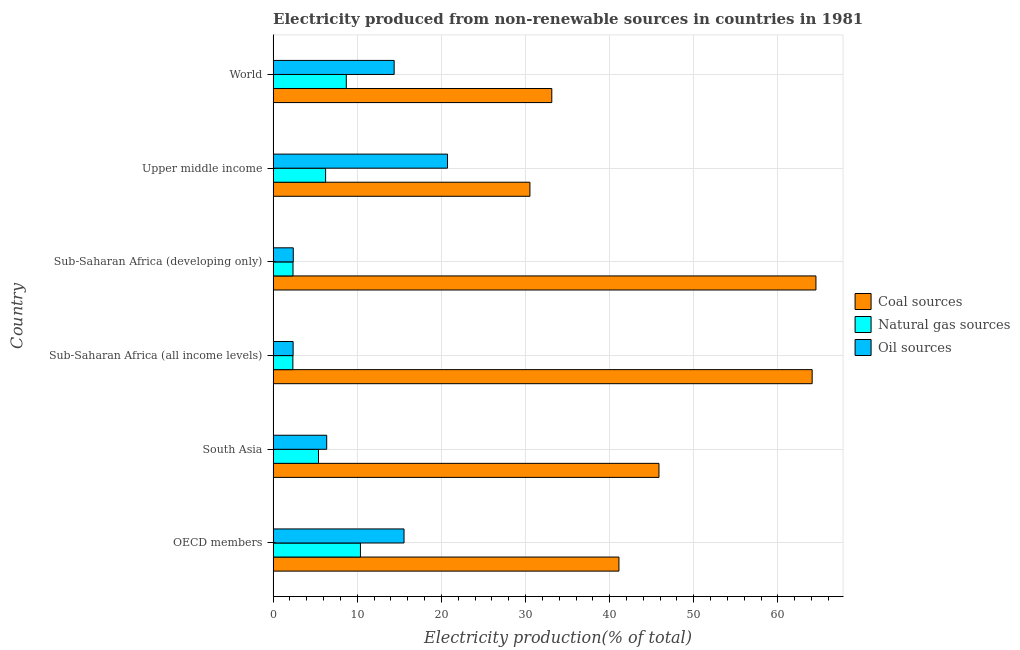Are the number of bars per tick equal to the number of legend labels?
Provide a succinct answer. Yes. Are the number of bars on each tick of the Y-axis equal?
Give a very brief answer. Yes. How many bars are there on the 5th tick from the top?
Keep it short and to the point. 3. In how many cases, is the number of bars for a given country not equal to the number of legend labels?
Give a very brief answer. 0. What is the percentage of electricity produced by natural gas in Sub-Saharan Africa (developing only)?
Make the answer very short. 2.36. Across all countries, what is the maximum percentage of electricity produced by coal?
Ensure brevity in your answer.  64.52. Across all countries, what is the minimum percentage of electricity produced by oil sources?
Your response must be concise. 2.38. In which country was the percentage of electricity produced by oil sources maximum?
Your response must be concise. Upper middle income. In which country was the percentage of electricity produced by oil sources minimum?
Provide a succinct answer. Sub-Saharan Africa (all income levels). What is the total percentage of electricity produced by oil sources in the graph?
Keep it short and to the point. 61.82. What is the difference between the percentage of electricity produced by natural gas in South Asia and that in World?
Ensure brevity in your answer.  -3.31. What is the difference between the percentage of electricity produced by coal in OECD members and the percentage of electricity produced by oil sources in Upper middle income?
Ensure brevity in your answer.  20.38. What is the average percentage of electricity produced by coal per country?
Provide a succinct answer. 46.53. Is the percentage of electricity produced by natural gas in OECD members less than that in South Asia?
Offer a terse response. No. What is the difference between the highest and the second highest percentage of electricity produced by coal?
Ensure brevity in your answer.  0.45. Is the sum of the percentage of electricity produced by natural gas in Sub-Saharan Africa (developing only) and World greater than the maximum percentage of electricity produced by oil sources across all countries?
Offer a terse response. No. What does the 2nd bar from the top in OECD members represents?
Provide a succinct answer. Natural gas sources. What does the 2nd bar from the bottom in Sub-Saharan Africa (all income levels) represents?
Ensure brevity in your answer.  Natural gas sources. Does the graph contain any zero values?
Provide a short and direct response. No. What is the title of the graph?
Provide a succinct answer. Electricity produced from non-renewable sources in countries in 1981. What is the Electricity production(% of total) of Coal sources in OECD members?
Give a very brief answer. 41.11. What is the Electricity production(% of total) in Natural gas sources in OECD members?
Ensure brevity in your answer.  10.38. What is the Electricity production(% of total) of Oil sources in OECD members?
Your answer should be very brief. 15.56. What is the Electricity production(% of total) in Coal sources in South Asia?
Your response must be concise. 45.86. What is the Electricity production(% of total) in Natural gas sources in South Asia?
Provide a short and direct response. 5.39. What is the Electricity production(% of total) of Oil sources in South Asia?
Provide a short and direct response. 6.37. What is the Electricity production(% of total) of Coal sources in Sub-Saharan Africa (all income levels)?
Keep it short and to the point. 64.07. What is the Electricity production(% of total) of Natural gas sources in Sub-Saharan Africa (all income levels)?
Offer a terse response. 2.35. What is the Electricity production(% of total) of Oil sources in Sub-Saharan Africa (all income levels)?
Offer a terse response. 2.38. What is the Electricity production(% of total) in Coal sources in Sub-Saharan Africa (developing only)?
Keep it short and to the point. 64.52. What is the Electricity production(% of total) in Natural gas sources in Sub-Saharan Africa (developing only)?
Make the answer very short. 2.36. What is the Electricity production(% of total) of Oil sources in Sub-Saharan Africa (developing only)?
Your answer should be compact. 2.39. What is the Electricity production(% of total) of Coal sources in Upper middle income?
Ensure brevity in your answer.  30.52. What is the Electricity production(% of total) of Natural gas sources in Upper middle income?
Provide a succinct answer. 6.24. What is the Electricity production(% of total) of Oil sources in Upper middle income?
Your response must be concise. 20.73. What is the Electricity production(% of total) in Coal sources in World?
Provide a succinct answer. 33.12. What is the Electricity production(% of total) of Natural gas sources in World?
Your answer should be compact. 8.7. What is the Electricity production(% of total) of Oil sources in World?
Make the answer very short. 14.39. Across all countries, what is the maximum Electricity production(% of total) of Coal sources?
Offer a terse response. 64.52. Across all countries, what is the maximum Electricity production(% of total) of Natural gas sources?
Ensure brevity in your answer.  10.38. Across all countries, what is the maximum Electricity production(% of total) of Oil sources?
Your answer should be very brief. 20.73. Across all countries, what is the minimum Electricity production(% of total) in Coal sources?
Offer a very short reply. 30.52. Across all countries, what is the minimum Electricity production(% of total) in Natural gas sources?
Your answer should be compact. 2.35. Across all countries, what is the minimum Electricity production(% of total) in Oil sources?
Offer a terse response. 2.38. What is the total Electricity production(% of total) in Coal sources in the graph?
Your response must be concise. 279.2. What is the total Electricity production(% of total) of Natural gas sources in the graph?
Ensure brevity in your answer.  35.42. What is the total Electricity production(% of total) of Oil sources in the graph?
Make the answer very short. 61.82. What is the difference between the Electricity production(% of total) of Coal sources in OECD members and that in South Asia?
Provide a short and direct response. -4.76. What is the difference between the Electricity production(% of total) in Natural gas sources in OECD members and that in South Asia?
Give a very brief answer. 4.99. What is the difference between the Electricity production(% of total) in Oil sources in OECD members and that in South Asia?
Offer a very short reply. 9.19. What is the difference between the Electricity production(% of total) of Coal sources in OECD members and that in Sub-Saharan Africa (all income levels)?
Your answer should be compact. -22.97. What is the difference between the Electricity production(% of total) in Natural gas sources in OECD members and that in Sub-Saharan Africa (all income levels)?
Make the answer very short. 8.03. What is the difference between the Electricity production(% of total) in Oil sources in OECD members and that in Sub-Saharan Africa (all income levels)?
Make the answer very short. 13.18. What is the difference between the Electricity production(% of total) in Coal sources in OECD members and that in Sub-Saharan Africa (developing only)?
Provide a succinct answer. -23.41. What is the difference between the Electricity production(% of total) of Natural gas sources in OECD members and that in Sub-Saharan Africa (developing only)?
Offer a very short reply. 8.02. What is the difference between the Electricity production(% of total) of Oil sources in OECD members and that in Sub-Saharan Africa (developing only)?
Your answer should be compact. 13.17. What is the difference between the Electricity production(% of total) in Coal sources in OECD members and that in Upper middle income?
Your answer should be compact. 10.58. What is the difference between the Electricity production(% of total) of Natural gas sources in OECD members and that in Upper middle income?
Give a very brief answer. 4.14. What is the difference between the Electricity production(% of total) in Oil sources in OECD members and that in Upper middle income?
Give a very brief answer. -5.17. What is the difference between the Electricity production(% of total) in Coal sources in OECD members and that in World?
Keep it short and to the point. 7.98. What is the difference between the Electricity production(% of total) of Natural gas sources in OECD members and that in World?
Your response must be concise. 1.68. What is the difference between the Electricity production(% of total) in Oil sources in OECD members and that in World?
Your answer should be very brief. 1.17. What is the difference between the Electricity production(% of total) in Coal sources in South Asia and that in Sub-Saharan Africa (all income levels)?
Give a very brief answer. -18.21. What is the difference between the Electricity production(% of total) of Natural gas sources in South Asia and that in Sub-Saharan Africa (all income levels)?
Your answer should be compact. 3.05. What is the difference between the Electricity production(% of total) in Oil sources in South Asia and that in Sub-Saharan Africa (all income levels)?
Provide a short and direct response. 3.99. What is the difference between the Electricity production(% of total) of Coal sources in South Asia and that in Sub-Saharan Africa (developing only)?
Make the answer very short. -18.66. What is the difference between the Electricity production(% of total) in Natural gas sources in South Asia and that in Sub-Saharan Africa (developing only)?
Your answer should be compact. 3.03. What is the difference between the Electricity production(% of total) of Oil sources in South Asia and that in Sub-Saharan Africa (developing only)?
Offer a terse response. 3.98. What is the difference between the Electricity production(% of total) in Coal sources in South Asia and that in Upper middle income?
Provide a succinct answer. 15.34. What is the difference between the Electricity production(% of total) in Natural gas sources in South Asia and that in Upper middle income?
Your response must be concise. -0.85. What is the difference between the Electricity production(% of total) in Oil sources in South Asia and that in Upper middle income?
Offer a very short reply. -14.36. What is the difference between the Electricity production(% of total) of Coal sources in South Asia and that in World?
Your response must be concise. 12.74. What is the difference between the Electricity production(% of total) of Natural gas sources in South Asia and that in World?
Your response must be concise. -3.3. What is the difference between the Electricity production(% of total) of Oil sources in South Asia and that in World?
Provide a short and direct response. -8.02. What is the difference between the Electricity production(% of total) in Coal sources in Sub-Saharan Africa (all income levels) and that in Sub-Saharan Africa (developing only)?
Offer a very short reply. -0.45. What is the difference between the Electricity production(% of total) of Natural gas sources in Sub-Saharan Africa (all income levels) and that in Sub-Saharan Africa (developing only)?
Provide a succinct answer. -0.02. What is the difference between the Electricity production(% of total) in Oil sources in Sub-Saharan Africa (all income levels) and that in Sub-Saharan Africa (developing only)?
Keep it short and to the point. -0.02. What is the difference between the Electricity production(% of total) in Coal sources in Sub-Saharan Africa (all income levels) and that in Upper middle income?
Offer a very short reply. 33.55. What is the difference between the Electricity production(% of total) of Natural gas sources in Sub-Saharan Africa (all income levels) and that in Upper middle income?
Offer a very short reply. -3.89. What is the difference between the Electricity production(% of total) in Oil sources in Sub-Saharan Africa (all income levels) and that in Upper middle income?
Provide a short and direct response. -18.35. What is the difference between the Electricity production(% of total) in Coal sources in Sub-Saharan Africa (all income levels) and that in World?
Your answer should be compact. 30.95. What is the difference between the Electricity production(% of total) in Natural gas sources in Sub-Saharan Africa (all income levels) and that in World?
Provide a short and direct response. -6.35. What is the difference between the Electricity production(% of total) in Oil sources in Sub-Saharan Africa (all income levels) and that in World?
Offer a very short reply. -12.01. What is the difference between the Electricity production(% of total) in Coal sources in Sub-Saharan Africa (developing only) and that in Upper middle income?
Your answer should be compact. 34. What is the difference between the Electricity production(% of total) in Natural gas sources in Sub-Saharan Africa (developing only) and that in Upper middle income?
Offer a very short reply. -3.88. What is the difference between the Electricity production(% of total) in Oil sources in Sub-Saharan Africa (developing only) and that in Upper middle income?
Your response must be concise. -18.34. What is the difference between the Electricity production(% of total) in Coal sources in Sub-Saharan Africa (developing only) and that in World?
Make the answer very short. 31.39. What is the difference between the Electricity production(% of total) of Natural gas sources in Sub-Saharan Africa (developing only) and that in World?
Your response must be concise. -6.33. What is the difference between the Electricity production(% of total) of Oil sources in Sub-Saharan Africa (developing only) and that in World?
Provide a succinct answer. -11.99. What is the difference between the Electricity production(% of total) of Coal sources in Upper middle income and that in World?
Provide a succinct answer. -2.6. What is the difference between the Electricity production(% of total) in Natural gas sources in Upper middle income and that in World?
Your answer should be very brief. -2.46. What is the difference between the Electricity production(% of total) of Oil sources in Upper middle income and that in World?
Provide a short and direct response. 6.34. What is the difference between the Electricity production(% of total) of Coal sources in OECD members and the Electricity production(% of total) of Natural gas sources in South Asia?
Your response must be concise. 35.71. What is the difference between the Electricity production(% of total) in Coal sources in OECD members and the Electricity production(% of total) in Oil sources in South Asia?
Ensure brevity in your answer.  34.74. What is the difference between the Electricity production(% of total) of Natural gas sources in OECD members and the Electricity production(% of total) of Oil sources in South Asia?
Offer a very short reply. 4.01. What is the difference between the Electricity production(% of total) in Coal sources in OECD members and the Electricity production(% of total) in Natural gas sources in Sub-Saharan Africa (all income levels)?
Provide a short and direct response. 38.76. What is the difference between the Electricity production(% of total) in Coal sources in OECD members and the Electricity production(% of total) in Oil sources in Sub-Saharan Africa (all income levels)?
Make the answer very short. 38.73. What is the difference between the Electricity production(% of total) in Natural gas sources in OECD members and the Electricity production(% of total) in Oil sources in Sub-Saharan Africa (all income levels)?
Keep it short and to the point. 8. What is the difference between the Electricity production(% of total) of Coal sources in OECD members and the Electricity production(% of total) of Natural gas sources in Sub-Saharan Africa (developing only)?
Provide a short and direct response. 38.74. What is the difference between the Electricity production(% of total) in Coal sources in OECD members and the Electricity production(% of total) in Oil sources in Sub-Saharan Africa (developing only)?
Your answer should be compact. 38.71. What is the difference between the Electricity production(% of total) in Natural gas sources in OECD members and the Electricity production(% of total) in Oil sources in Sub-Saharan Africa (developing only)?
Make the answer very short. 7.99. What is the difference between the Electricity production(% of total) in Coal sources in OECD members and the Electricity production(% of total) in Natural gas sources in Upper middle income?
Your response must be concise. 34.87. What is the difference between the Electricity production(% of total) of Coal sources in OECD members and the Electricity production(% of total) of Oil sources in Upper middle income?
Your response must be concise. 20.38. What is the difference between the Electricity production(% of total) of Natural gas sources in OECD members and the Electricity production(% of total) of Oil sources in Upper middle income?
Make the answer very short. -10.35. What is the difference between the Electricity production(% of total) in Coal sources in OECD members and the Electricity production(% of total) in Natural gas sources in World?
Your response must be concise. 32.41. What is the difference between the Electricity production(% of total) of Coal sources in OECD members and the Electricity production(% of total) of Oil sources in World?
Ensure brevity in your answer.  26.72. What is the difference between the Electricity production(% of total) of Natural gas sources in OECD members and the Electricity production(% of total) of Oil sources in World?
Give a very brief answer. -4.01. What is the difference between the Electricity production(% of total) of Coal sources in South Asia and the Electricity production(% of total) of Natural gas sources in Sub-Saharan Africa (all income levels)?
Make the answer very short. 43.51. What is the difference between the Electricity production(% of total) of Coal sources in South Asia and the Electricity production(% of total) of Oil sources in Sub-Saharan Africa (all income levels)?
Make the answer very short. 43.48. What is the difference between the Electricity production(% of total) of Natural gas sources in South Asia and the Electricity production(% of total) of Oil sources in Sub-Saharan Africa (all income levels)?
Provide a short and direct response. 3.02. What is the difference between the Electricity production(% of total) in Coal sources in South Asia and the Electricity production(% of total) in Natural gas sources in Sub-Saharan Africa (developing only)?
Your response must be concise. 43.5. What is the difference between the Electricity production(% of total) of Coal sources in South Asia and the Electricity production(% of total) of Oil sources in Sub-Saharan Africa (developing only)?
Keep it short and to the point. 43.47. What is the difference between the Electricity production(% of total) of Natural gas sources in South Asia and the Electricity production(% of total) of Oil sources in Sub-Saharan Africa (developing only)?
Keep it short and to the point. 3. What is the difference between the Electricity production(% of total) of Coal sources in South Asia and the Electricity production(% of total) of Natural gas sources in Upper middle income?
Your response must be concise. 39.62. What is the difference between the Electricity production(% of total) in Coal sources in South Asia and the Electricity production(% of total) in Oil sources in Upper middle income?
Ensure brevity in your answer.  25.13. What is the difference between the Electricity production(% of total) in Natural gas sources in South Asia and the Electricity production(% of total) in Oil sources in Upper middle income?
Provide a short and direct response. -15.34. What is the difference between the Electricity production(% of total) of Coal sources in South Asia and the Electricity production(% of total) of Natural gas sources in World?
Provide a succinct answer. 37.16. What is the difference between the Electricity production(% of total) of Coal sources in South Asia and the Electricity production(% of total) of Oil sources in World?
Ensure brevity in your answer.  31.48. What is the difference between the Electricity production(% of total) in Natural gas sources in South Asia and the Electricity production(% of total) in Oil sources in World?
Keep it short and to the point. -8.99. What is the difference between the Electricity production(% of total) of Coal sources in Sub-Saharan Africa (all income levels) and the Electricity production(% of total) of Natural gas sources in Sub-Saharan Africa (developing only)?
Provide a short and direct response. 61.71. What is the difference between the Electricity production(% of total) of Coal sources in Sub-Saharan Africa (all income levels) and the Electricity production(% of total) of Oil sources in Sub-Saharan Africa (developing only)?
Your answer should be very brief. 61.68. What is the difference between the Electricity production(% of total) in Natural gas sources in Sub-Saharan Africa (all income levels) and the Electricity production(% of total) in Oil sources in Sub-Saharan Africa (developing only)?
Keep it short and to the point. -0.05. What is the difference between the Electricity production(% of total) in Coal sources in Sub-Saharan Africa (all income levels) and the Electricity production(% of total) in Natural gas sources in Upper middle income?
Ensure brevity in your answer.  57.83. What is the difference between the Electricity production(% of total) in Coal sources in Sub-Saharan Africa (all income levels) and the Electricity production(% of total) in Oil sources in Upper middle income?
Provide a short and direct response. 43.34. What is the difference between the Electricity production(% of total) of Natural gas sources in Sub-Saharan Africa (all income levels) and the Electricity production(% of total) of Oil sources in Upper middle income?
Your answer should be very brief. -18.38. What is the difference between the Electricity production(% of total) of Coal sources in Sub-Saharan Africa (all income levels) and the Electricity production(% of total) of Natural gas sources in World?
Your answer should be compact. 55.37. What is the difference between the Electricity production(% of total) in Coal sources in Sub-Saharan Africa (all income levels) and the Electricity production(% of total) in Oil sources in World?
Provide a succinct answer. 49.68. What is the difference between the Electricity production(% of total) in Natural gas sources in Sub-Saharan Africa (all income levels) and the Electricity production(% of total) in Oil sources in World?
Offer a very short reply. -12.04. What is the difference between the Electricity production(% of total) of Coal sources in Sub-Saharan Africa (developing only) and the Electricity production(% of total) of Natural gas sources in Upper middle income?
Your response must be concise. 58.28. What is the difference between the Electricity production(% of total) of Coal sources in Sub-Saharan Africa (developing only) and the Electricity production(% of total) of Oil sources in Upper middle income?
Ensure brevity in your answer.  43.79. What is the difference between the Electricity production(% of total) of Natural gas sources in Sub-Saharan Africa (developing only) and the Electricity production(% of total) of Oil sources in Upper middle income?
Your response must be concise. -18.37. What is the difference between the Electricity production(% of total) of Coal sources in Sub-Saharan Africa (developing only) and the Electricity production(% of total) of Natural gas sources in World?
Offer a terse response. 55.82. What is the difference between the Electricity production(% of total) in Coal sources in Sub-Saharan Africa (developing only) and the Electricity production(% of total) in Oil sources in World?
Keep it short and to the point. 50.13. What is the difference between the Electricity production(% of total) in Natural gas sources in Sub-Saharan Africa (developing only) and the Electricity production(% of total) in Oil sources in World?
Offer a terse response. -12.02. What is the difference between the Electricity production(% of total) in Coal sources in Upper middle income and the Electricity production(% of total) in Natural gas sources in World?
Make the answer very short. 21.83. What is the difference between the Electricity production(% of total) in Coal sources in Upper middle income and the Electricity production(% of total) in Oil sources in World?
Your answer should be very brief. 16.14. What is the difference between the Electricity production(% of total) in Natural gas sources in Upper middle income and the Electricity production(% of total) in Oil sources in World?
Make the answer very short. -8.15. What is the average Electricity production(% of total) of Coal sources per country?
Provide a short and direct response. 46.53. What is the average Electricity production(% of total) of Natural gas sources per country?
Make the answer very short. 5.9. What is the average Electricity production(% of total) in Oil sources per country?
Provide a short and direct response. 10.3. What is the difference between the Electricity production(% of total) in Coal sources and Electricity production(% of total) in Natural gas sources in OECD members?
Your response must be concise. 30.72. What is the difference between the Electricity production(% of total) of Coal sources and Electricity production(% of total) of Oil sources in OECD members?
Provide a short and direct response. 25.54. What is the difference between the Electricity production(% of total) of Natural gas sources and Electricity production(% of total) of Oil sources in OECD members?
Provide a succinct answer. -5.18. What is the difference between the Electricity production(% of total) in Coal sources and Electricity production(% of total) in Natural gas sources in South Asia?
Your answer should be compact. 40.47. What is the difference between the Electricity production(% of total) of Coal sources and Electricity production(% of total) of Oil sources in South Asia?
Offer a very short reply. 39.49. What is the difference between the Electricity production(% of total) of Natural gas sources and Electricity production(% of total) of Oil sources in South Asia?
Your answer should be compact. -0.98. What is the difference between the Electricity production(% of total) of Coal sources and Electricity production(% of total) of Natural gas sources in Sub-Saharan Africa (all income levels)?
Ensure brevity in your answer.  61.72. What is the difference between the Electricity production(% of total) in Coal sources and Electricity production(% of total) in Oil sources in Sub-Saharan Africa (all income levels)?
Your response must be concise. 61.69. What is the difference between the Electricity production(% of total) of Natural gas sources and Electricity production(% of total) of Oil sources in Sub-Saharan Africa (all income levels)?
Provide a succinct answer. -0.03. What is the difference between the Electricity production(% of total) in Coal sources and Electricity production(% of total) in Natural gas sources in Sub-Saharan Africa (developing only)?
Ensure brevity in your answer.  62.16. What is the difference between the Electricity production(% of total) of Coal sources and Electricity production(% of total) of Oil sources in Sub-Saharan Africa (developing only)?
Provide a succinct answer. 62.12. What is the difference between the Electricity production(% of total) of Natural gas sources and Electricity production(% of total) of Oil sources in Sub-Saharan Africa (developing only)?
Your response must be concise. -0.03. What is the difference between the Electricity production(% of total) of Coal sources and Electricity production(% of total) of Natural gas sources in Upper middle income?
Offer a very short reply. 24.28. What is the difference between the Electricity production(% of total) of Coal sources and Electricity production(% of total) of Oil sources in Upper middle income?
Give a very brief answer. 9.79. What is the difference between the Electricity production(% of total) in Natural gas sources and Electricity production(% of total) in Oil sources in Upper middle income?
Provide a short and direct response. -14.49. What is the difference between the Electricity production(% of total) of Coal sources and Electricity production(% of total) of Natural gas sources in World?
Provide a short and direct response. 24.43. What is the difference between the Electricity production(% of total) in Coal sources and Electricity production(% of total) in Oil sources in World?
Give a very brief answer. 18.74. What is the difference between the Electricity production(% of total) in Natural gas sources and Electricity production(% of total) in Oil sources in World?
Make the answer very short. -5.69. What is the ratio of the Electricity production(% of total) of Coal sources in OECD members to that in South Asia?
Ensure brevity in your answer.  0.9. What is the ratio of the Electricity production(% of total) in Natural gas sources in OECD members to that in South Asia?
Ensure brevity in your answer.  1.92. What is the ratio of the Electricity production(% of total) of Oil sources in OECD members to that in South Asia?
Your answer should be very brief. 2.44. What is the ratio of the Electricity production(% of total) in Coal sources in OECD members to that in Sub-Saharan Africa (all income levels)?
Make the answer very short. 0.64. What is the ratio of the Electricity production(% of total) in Natural gas sources in OECD members to that in Sub-Saharan Africa (all income levels)?
Ensure brevity in your answer.  4.42. What is the ratio of the Electricity production(% of total) of Oil sources in OECD members to that in Sub-Saharan Africa (all income levels)?
Your response must be concise. 6.54. What is the ratio of the Electricity production(% of total) of Coal sources in OECD members to that in Sub-Saharan Africa (developing only)?
Your answer should be very brief. 0.64. What is the ratio of the Electricity production(% of total) in Natural gas sources in OECD members to that in Sub-Saharan Africa (developing only)?
Your answer should be compact. 4.39. What is the ratio of the Electricity production(% of total) in Oil sources in OECD members to that in Sub-Saharan Africa (developing only)?
Your response must be concise. 6.5. What is the ratio of the Electricity production(% of total) in Coal sources in OECD members to that in Upper middle income?
Offer a very short reply. 1.35. What is the ratio of the Electricity production(% of total) of Natural gas sources in OECD members to that in Upper middle income?
Offer a very short reply. 1.66. What is the ratio of the Electricity production(% of total) in Oil sources in OECD members to that in Upper middle income?
Ensure brevity in your answer.  0.75. What is the ratio of the Electricity production(% of total) in Coal sources in OECD members to that in World?
Your response must be concise. 1.24. What is the ratio of the Electricity production(% of total) of Natural gas sources in OECD members to that in World?
Keep it short and to the point. 1.19. What is the ratio of the Electricity production(% of total) in Oil sources in OECD members to that in World?
Your response must be concise. 1.08. What is the ratio of the Electricity production(% of total) in Coal sources in South Asia to that in Sub-Saharan Africa (all income levels)?
Offer a very short reply. 0.72. What is the ratio of the Electricity production(% of total) of Natural gas sources in South Asia to that in Sub-Saharan Africa (all income levels)?
Make the answer very short. 2.3. What is the ratio of the Electricity production(% of total) of Oil sources in South Asia to that in Sub-Saharan Africa (all income levels)?
Give a very brief answer. 2.68. What is the ratio of the Electricity production(% of total) of Coal sources in South Asia to that in Sub-Saharan Africa (developing only)?
Offer a very short reply. 0.71. What is the ratio of the Electricity production(% of total) of Natural gas sources in South Asia to that in Sub-Saharan Africa (developing only)?
Offer a terse response. 2.28. What is the ratio of the Electricity production(% of total) in Oil sources in South Asia to that in Sub-Saharan Africa (developing only)?
Offer a terse response. 2.66. What is the ratio of the Electricity production(% of total) of Coal sources in South Asia to that in Upper middle income?
Make the answer very short. 1.5. What is the ratio of the Electricity production(% of total) of Natural gas sources in South Asia to that in Upper middle income?
Offer a very short reply. 0.86. What is the ratio of the Electricity production(% of total) of Oil sources in South Asia to that in Upper middle income?
Provide a short and direct response. 0.31. What is the ratio of the Electricity production(% of total) of Coal sources in South Asia to that in World?
Make the answer very short. 1.38. What is the ratio of the Electricity production(% of total) of Natural gas sources in South Asia to that in World?
Ensure brevity in your answer.  0.62. What is the ratio of the Electricity production(% of total) of Oil sources in South Asia to that in World?
Provide a succinct answer. 0.44. What is the ratio of the Electricity production(% of total) in Oil sources in Sub-Saharan Africa (all income levels) to that in Sub-Saharan Africa (developing only)?
Give a very brief answer. 0.99. What is the ratio of the Electricity production(% of total) of Coal sources in Sub-Saharan Africa (all income levels) to that in Upper middle income?
Offer a very short reply. 2.1. What is the ratio of the Electricity production(% of total) of Natural gas sources in Sub-Saharan Africa (all income levels) to that in Upper middle income?
Offer a very short reply. 0.38. What is the ratio of the Electricity production(% of total) of Oil sources in Sub-Saharan Africa (all income levels) to that in Upper middle income?
Ensure brevity in your answer.  0.11. What is the ratio of the Electricity production(% of total) in Coal sources in Sub-Saharan Africa (all income levels) to that in World?
Give a very brief answer. 1.93. What is the ratio of the Electricity production(% of total) in Natural gas sources in Sub-Saharan Africa (all income levels) to that in World?
Keep it short and to the point. 0.27. What is the ratio of the Electricity production(% of total) of Oil sources in Sub-Saharan Africa (all income levels) to that in World?
Provide a short and direct response. 0.17. What is the ratio of the Electricity production(% of total) of Coal sources in Sub-Saharan Africa (developing only) to that in Upper middle income?
Offer a terse response. 2.11. What is the ratio of the Electricity production(% of total) of Natural gas sources in Sub-Saharan Africa (developing only) to that in Upper middle income?
Offer a terse response. 0.38. What is the ratio of the Electricity production(% of total) of Oil sources in Sub-Saharan Africa (developing only) to that in Upper middle income?
Make the answer very short. 0.12. What is the ratio of the Electricity production(% of total) in Coal sources in Sub-Saharan Africa (developing only) to that in World?
Your answer should be very brief. 1.95. What is the ratio of the Electricity production(% of total) in Natural gas sources in Sub-Saharan Africa (developing only) to that in World?
Your answer should be very brief. 0.27. What is the ratio of the Electricity production(% of total) of Oil sources in Sub-Saharan Africa (developing only) to that in World?
Keep it short and to the point. 0.17. What is the ratio of the Electricity production(% of total) of Coal sources in Upper middle income to that in World?
Your answer should be compact. 0.92. What is the ratio of the Electricity production(% of total) of Natural gas sources in Upper middle income to that in World?
Make the answer very short. 0.72. What is the ratio of the Electricity production(% of total) of Oil sources in Upper middle income to that in World?
Keep it short and to the point. 1.44. What is the difference between the highest and the second highest Electricity production(% of total) of Coal sources?
Your answer should be compact. 0.45. What is the difference between the highest and the second highest Electricity production(% of total) of Natural gas sources?
Ensure brevity in your answer.  1.68. What is the difference between the highest and the second highest Electricity production(% of total) of Oil sources?
Provide a short and direct response. 5.17. What is the difference between the highest and the lowest Electricity production(% of total) of Coal sources?
Make the answer very short. 34. What is the difference between the highest and the lowest Electricity production(% of total) of Natural gas sources?
Your answer should be very brief. 8.03. What is the difference between the highest and the lowest Electricity production(% of total) of Oil sources?
Ensure brevity in your answer.  18.35. 